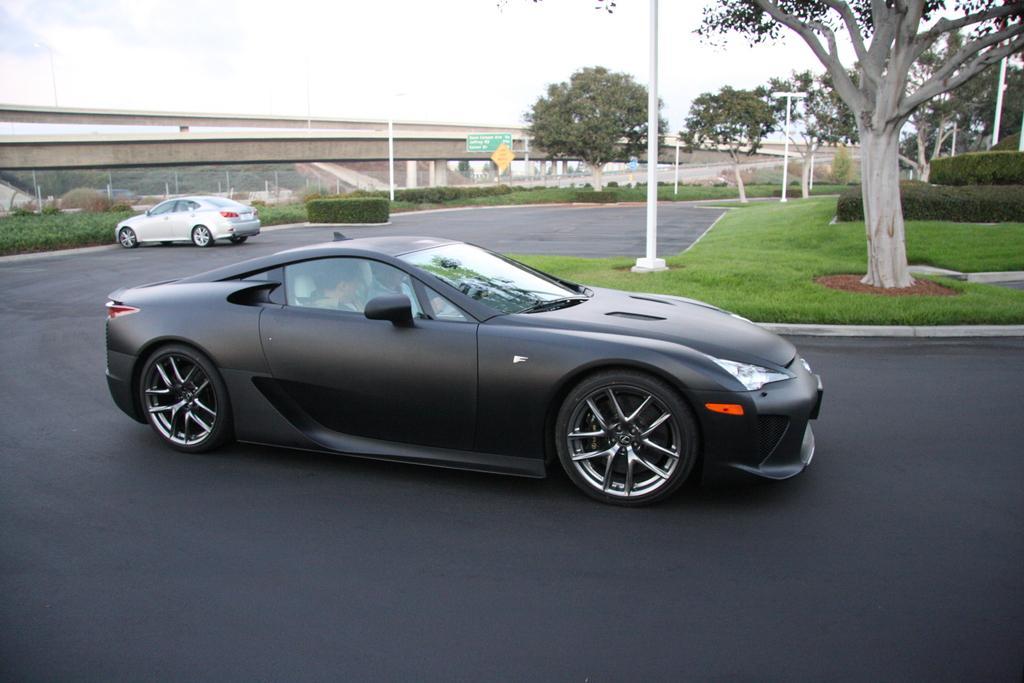Could you give a brief overview of what you see in this image? In the image we can see there are two cars of different colors on the road. In the car there are people sitting. Here we can see a bridge and trees around. We can even see there are light poles and grass. Here we can see a white cloudy sky. 